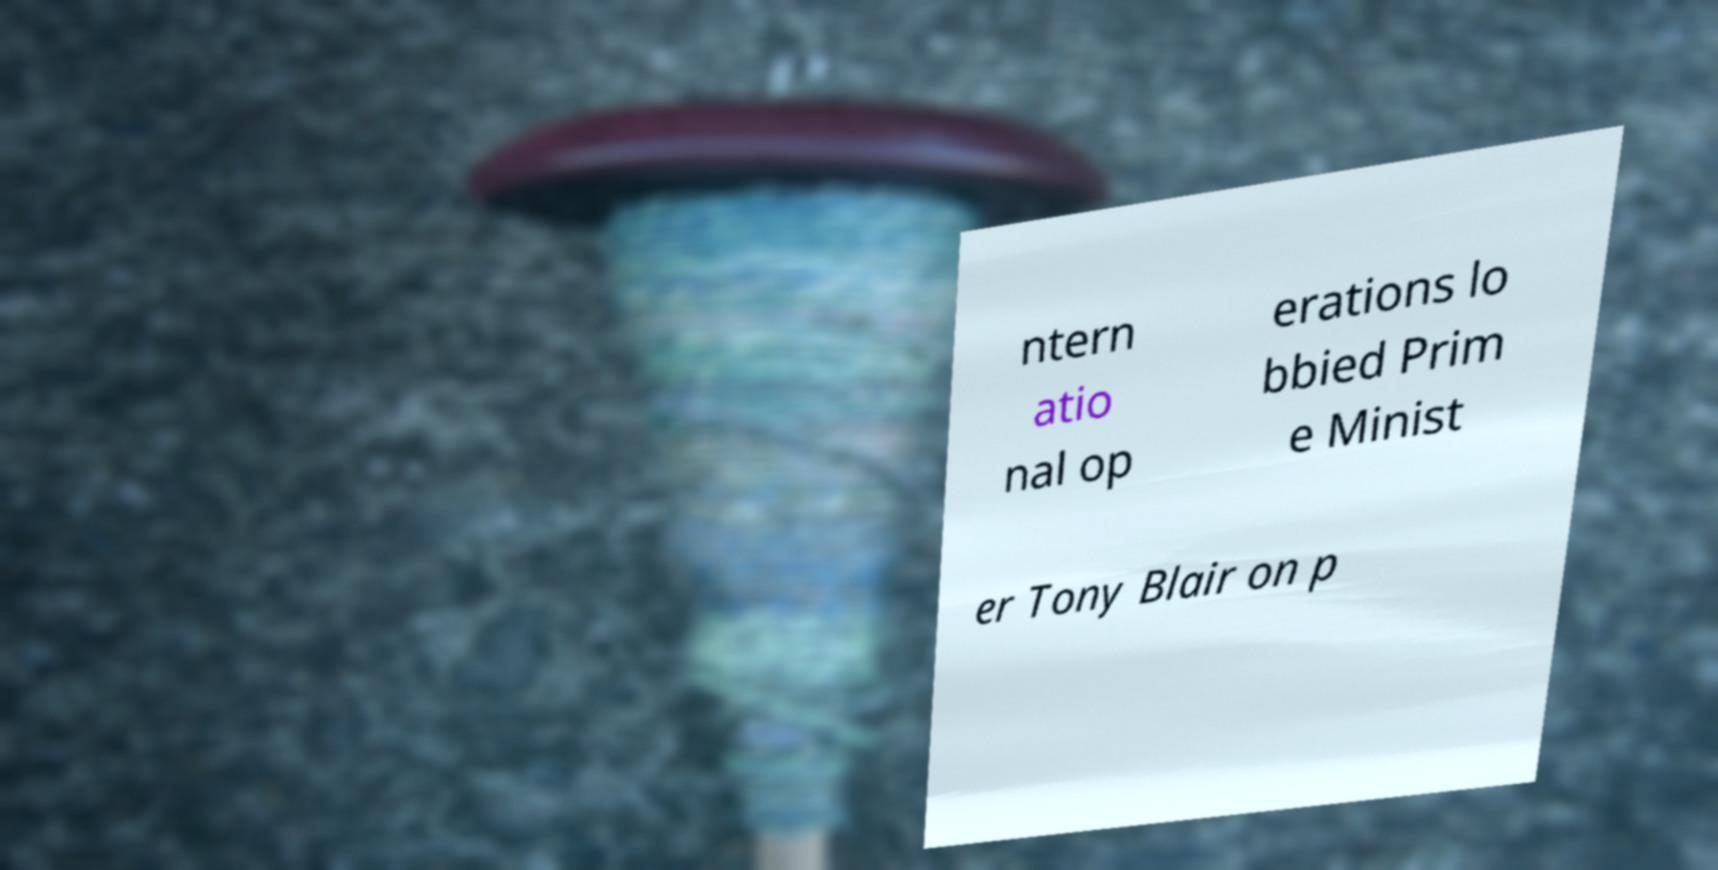Can you read and provide the text displayed in the image?This photo seems to have some interesting text. Can you extract and type it out for me? ntern atio nal op erations lo bbied Prim e Minist er Tony Blair on p 